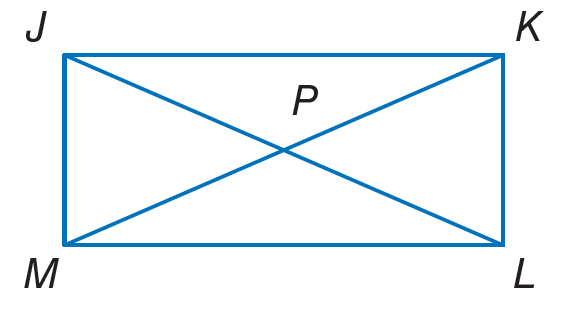Answer the mathemtical geometry problem and directly provide the correct option letter.
Question: Quadrilateral J K L M is a rectangle. If m \angle K J L = 2 x + 4 and m \angle J L K = 7 x + 5, find x.
Choices: A: 9 B: 22 C: 45 D: 68 A 